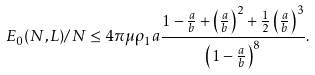<formula> <loc_0><loc_0><loc_500><loc_500>E _ { 0 } ( N , L ) / N \leq 4 \pi \mu \rho _ { 1 } a \frac { 1 - \frac { a } { b } + \left ( \frac { a } { b } \right ) ^ { 2 } + \frac { 1 } { 2 } \left ( \frac { a } { b } \right ) ^ { 3 } } { \left ( 1 - \frac { a } { b } \right ) ^ { 8 } } .</formula> 